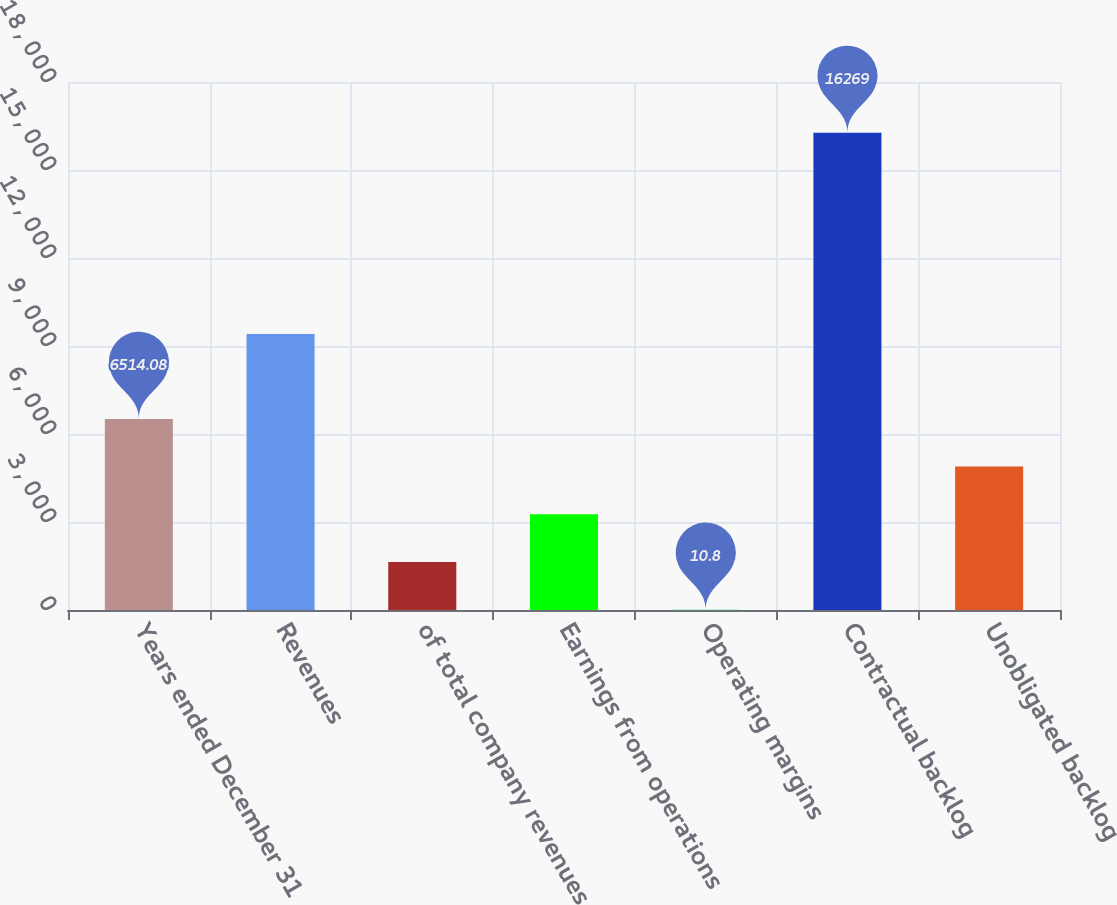<chart> <loc_0><loc_0><loc_500><loc_500><bar_chart><fcel>Years ended December 31<fcel>Revenues<fcel>of total company revenues<fcel>Earnings from operations<fcel>Operating margins<fcel>Contractual backlog<fcel>Unobligated backlog<nl><fcel>6514.08<fcel>9410<fcel>1636.62<fcel>3262.44<fcel>10.8<fcel>16269<fcel>4888.26<nl></chart> 